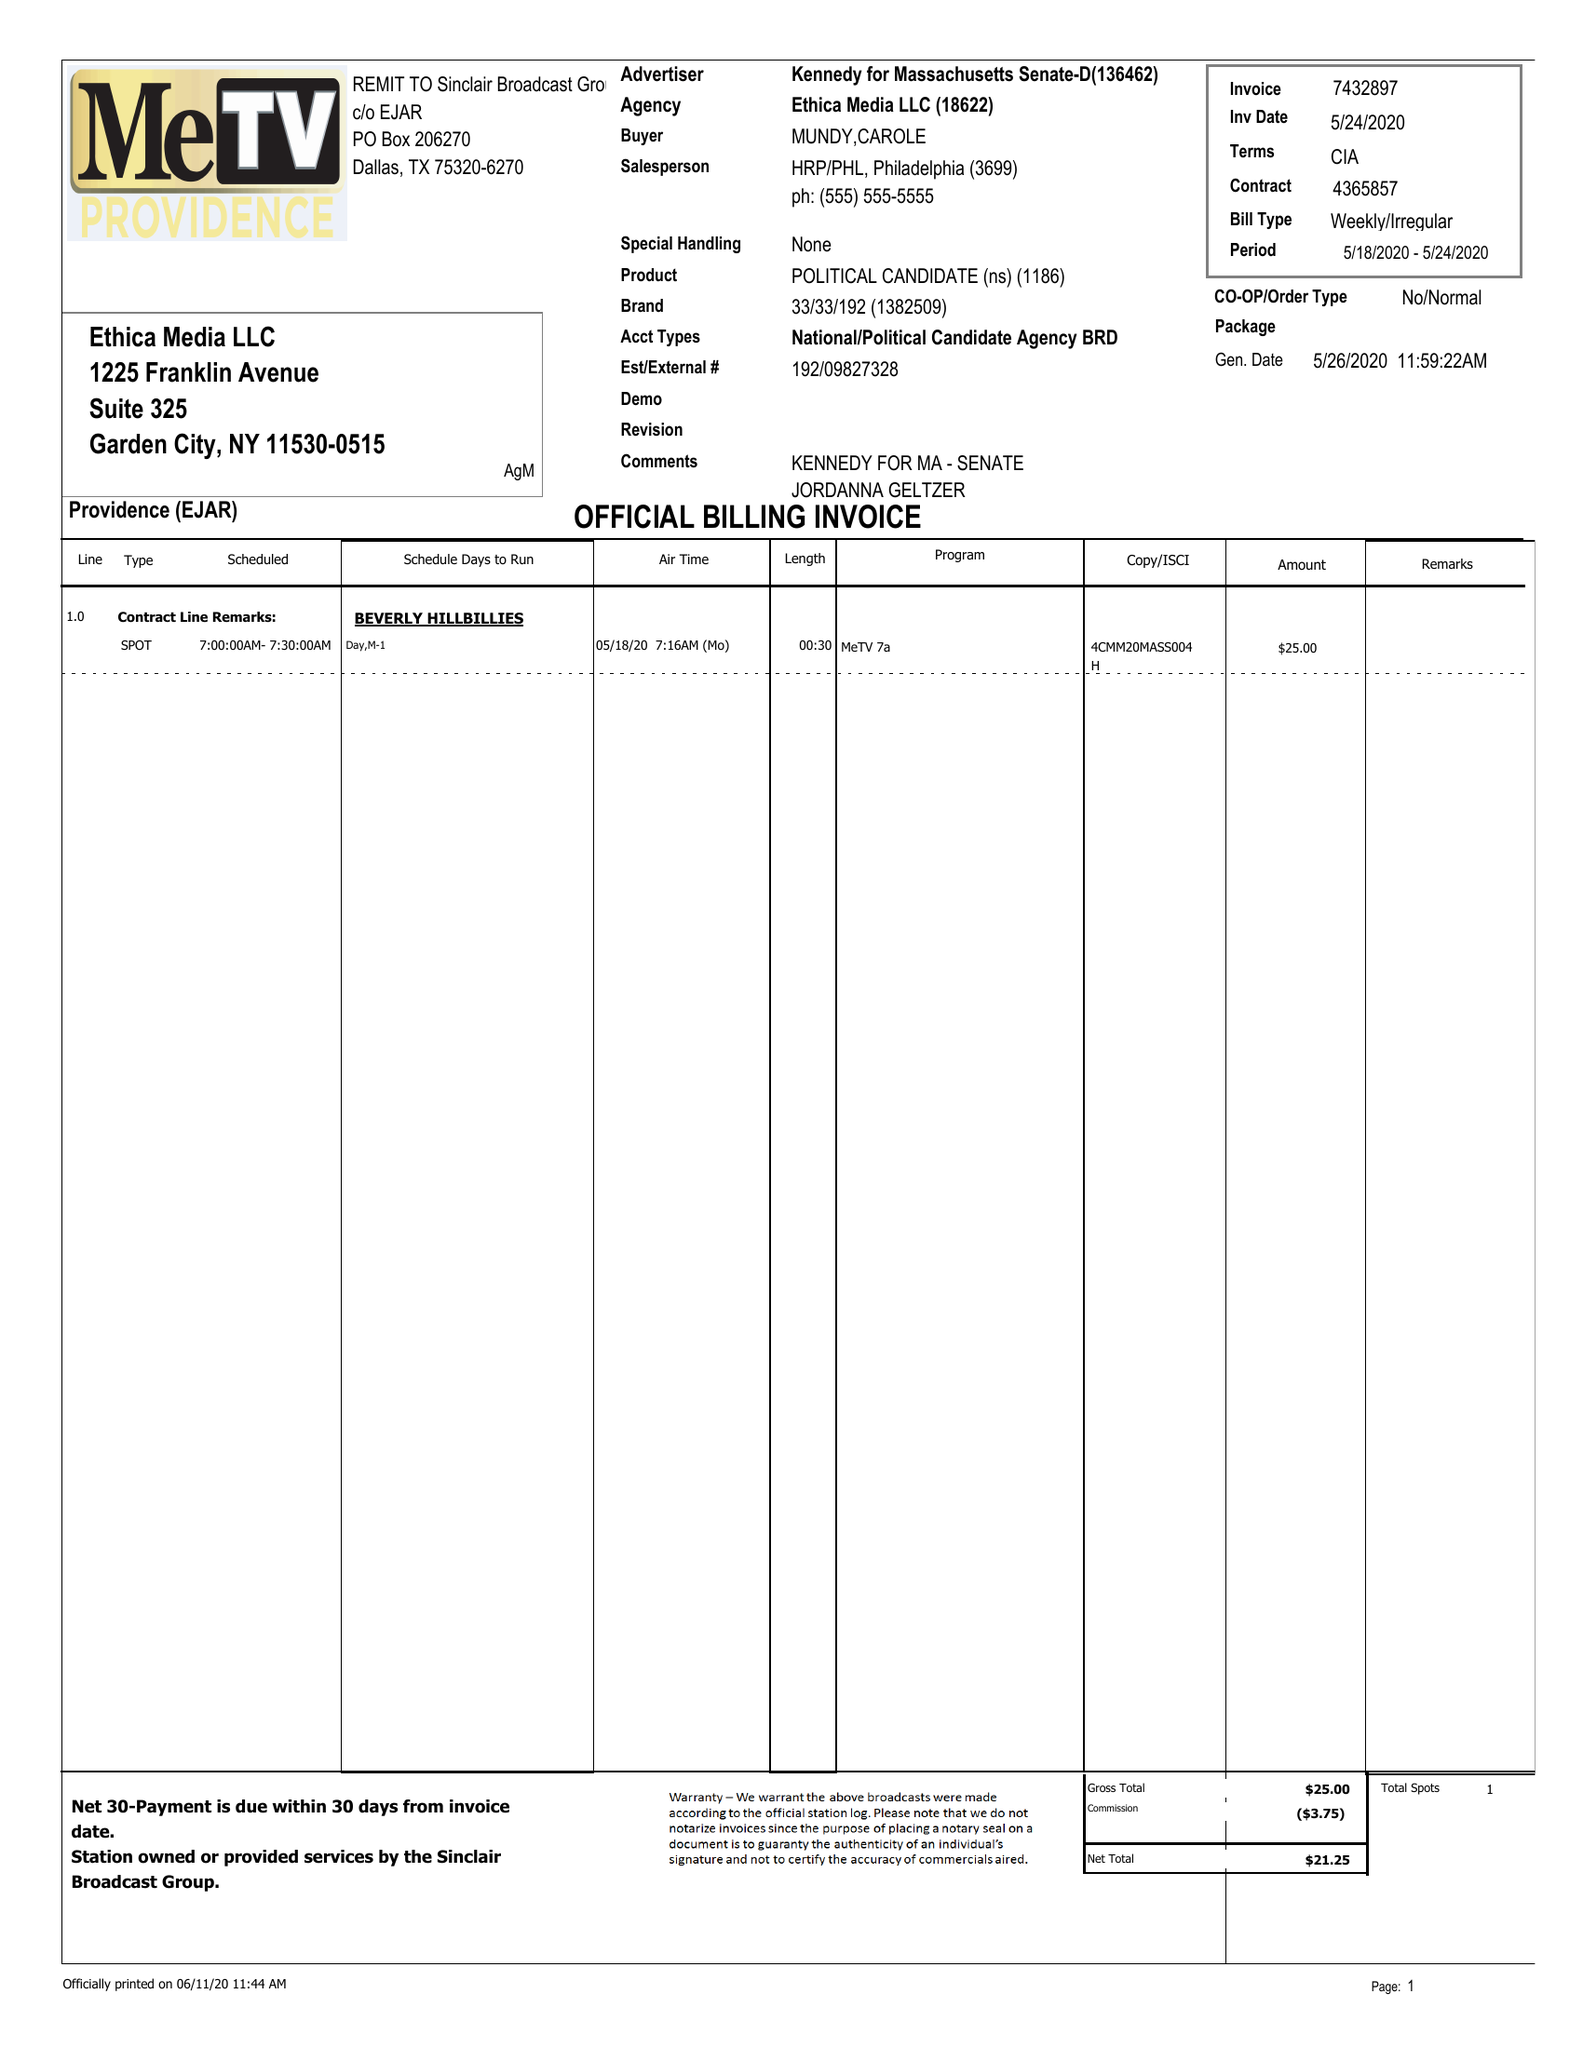What is the value for the gross_amount?
Answer the question using a single word or phrase. 25.00 